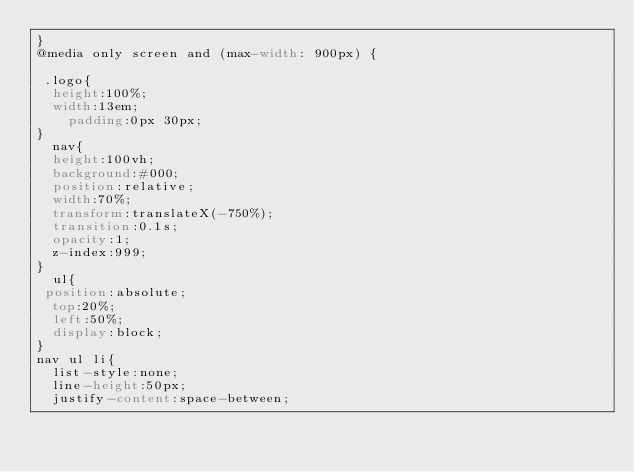<code> <loc_0><loc_0><loc_500><loc_500><_CSS_>}
@media only screen and (max-width: 900px) {
	
 .logo{
	height:100%;
	width:13em;
		padding:0px 30px;
}
  nav{
	height:100vh;
	background:#000;
	position:relative;
	width:70%;
	transform:translateX(-750%); 
	transition:0.1s;
	opacity:1;
	z-index:999;
}
  ul{
 position:absolute;
	top:20%;
	left:50%;
	display:block;
}
nav ul li{
	list-style:none;
	line-height:50px;
	justify-content:space-between;</code> 